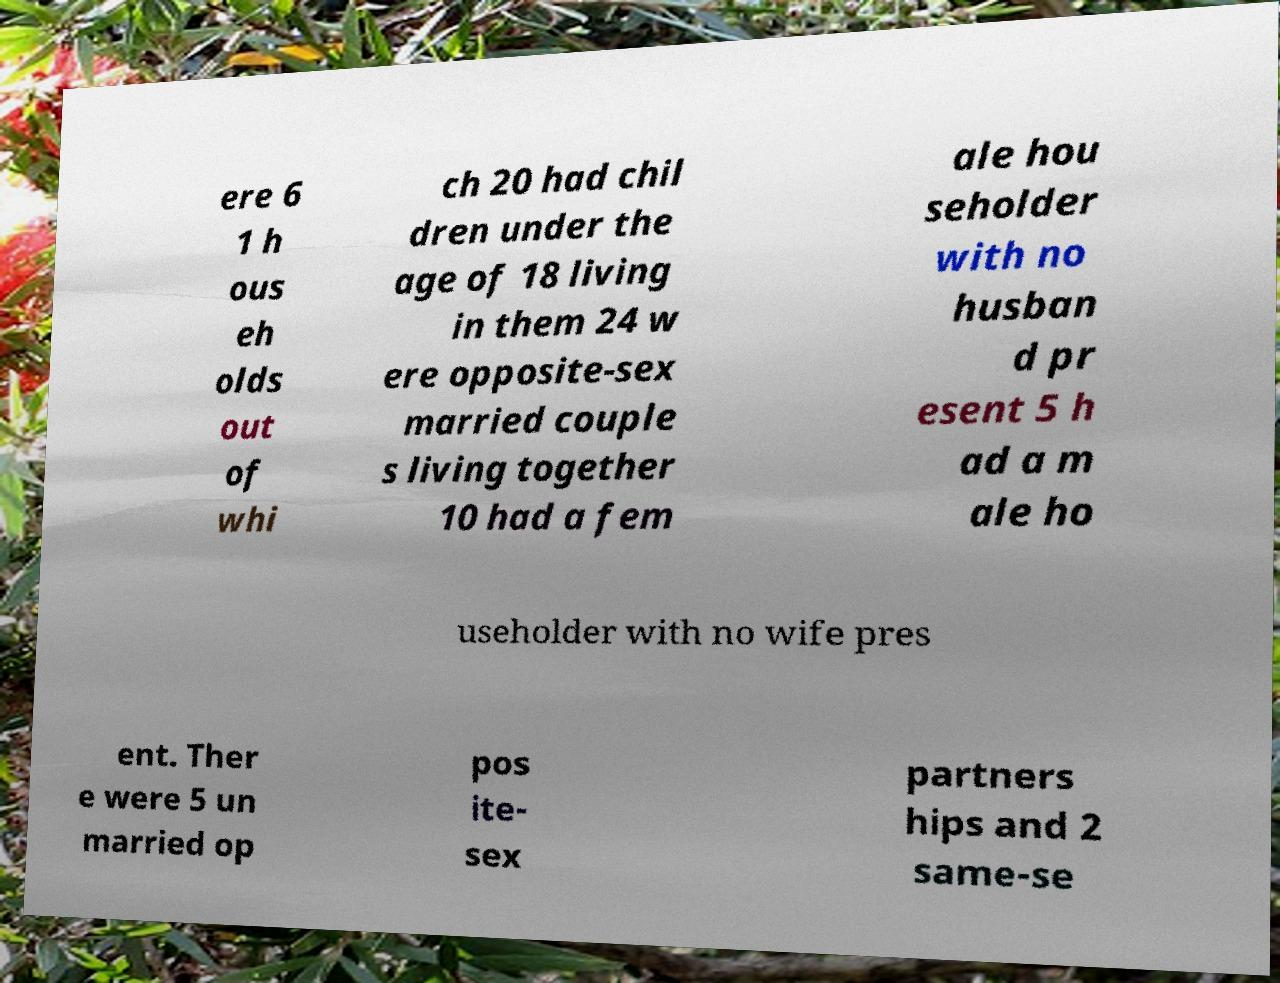I need the written content from this picture converted into text. Can you do that? ere 6 1 h ous eh olds out of whi ch 20 had chil dren under the age of 18 living in them 24 w ere opposite-sex married couple s living together 10 had a fem ale hou seholder with no husban d pr esent 5 h ad a m ale ho useholder with no wife pres ent. Ther e were 5 un married op pos ite- sex partners hips and 2 same-se 